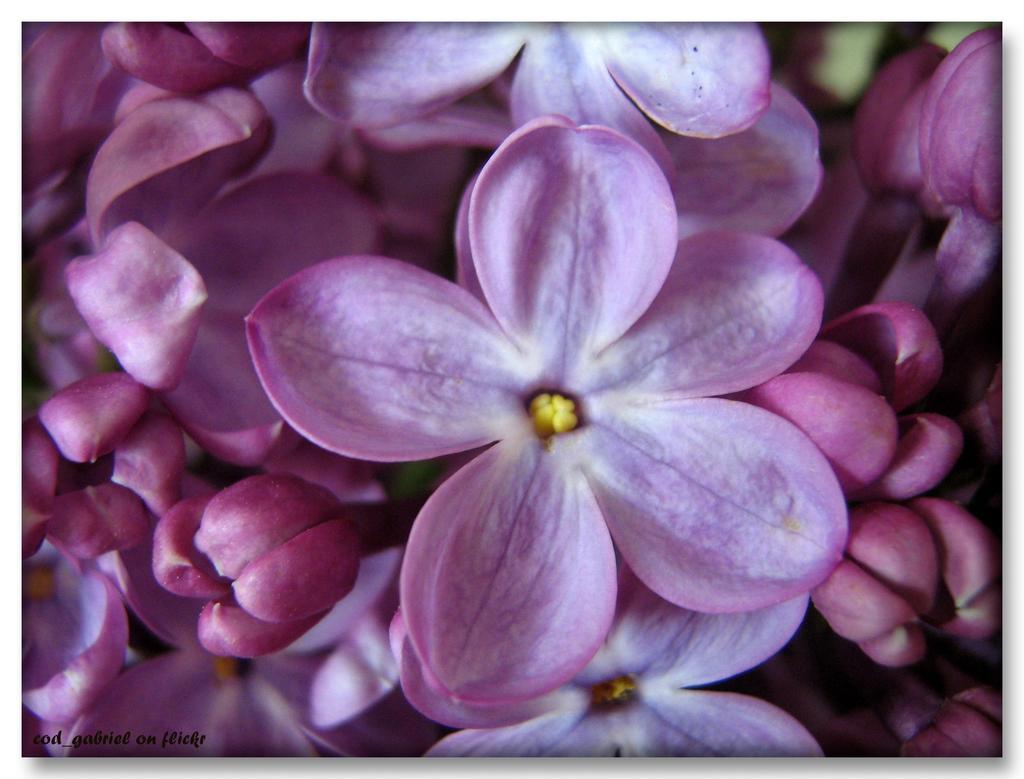How would you summarize this image in a sentence or two? This image consists of flowers in pink color. 